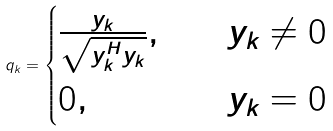Convert formula to latex. <formula><loc_0><loc_0><loc_500><loc_500>q _ { k } = \begin{cases} \frac { y _ { k } } { \sqrt { y _ { k } ^ { H } y _ { k } } } , & \quad y _ { k } \neq 0 \\ 0 , & \quad y _ { k } = 0 \end{cases}</formula> 